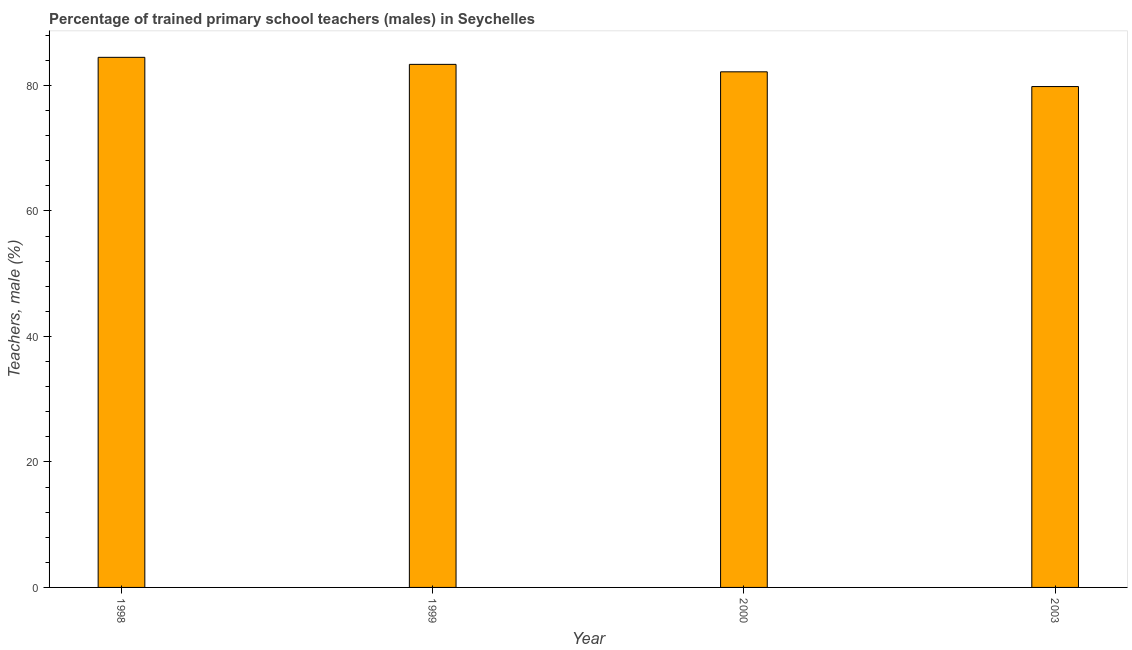Does the graph contain any zero values?
Offer a terse response. No. Does the graph contain grids?
Keep it short and to the point. No. What is the title of the graph?
Offer a terse response. Percentage of trained primary school teachers (males) in Seychelles. What is the label or title of the Y-axis?
Provide a short and direct response. Teachers, male (%). What is the percentage of trained male teachers in 2000?
Give a very brief answer. 82.17. Across all years, what is the maximum percentage of trained male teachers?
Provide a short and direct response. 84.48. Across all years, what is the minimum percentage of trained male teachers?
Give a very brief answer. 79.83. In which year was the percentage of trained male teachers minimum?
Give a very brief answer. 2003. What is the sum of the percentage of trained male teachers?
Offer a very short reply. 329.84. What is the difference between the percentage of trained male teachers in 1999 and 2003?
Your answer should be compact. 3.54. What is the average percentage of trained male teachers per year?
Offer a terse response. 82.46. What is the median percentage of trained male teachers?
Provide a short and direct response. 82.77. Do a majority of the years between 1998 and 2000 (inclusive) have percentage of trained male teachers greater than 20 %?
Your answer should be very brief. Yes. What is the ratio of the percentage of trained male teachers in 1998 to that in 1999?
Your answer should be very brief. 1.01. What is the difference between the highest and the second highest percentage of trained male teachers?
Keep it short and to the point. 1.12. Is the sum of the percentage of trained male teachers in 1998 and 1999 greater than the maximum percentage of trained male teachers across all years?
Keep it short and to the point. Yes. What is the difference between the highest and the lowest percentage of trained male teachers?
Offer a terse response. 4.66. In how many years, is the percentage of trained male teachers greater than the average percentage of trained male teachers taken over all years?
Make the answer very short. 2. Are all the bars in the graph horizontal?
Your answer should be very brief. No. Are the values on the major ticks of Y-axis written in scientific E-notation?
Offer a terse response. No. What is the Teachers, male (%) in 1998?
Ensure brevity in your answer.  84.48. What is the Teachers, male (%) in 1999?
Provide a succinct answer. 83.36. What is the Teachers, male (%) in 2000?
Provide a short and direct response. 82.17. What is the Teachers, male (%) in 2003?
Give a very brief answer. 79.83. What is the difference between the Teachers, male (%) in 1998 and 1999?
Offer a terse response. 1.12. What is the difference between the Teachers, male (%) in 1998 and 2000?
Give a very brief answer. 2.31. What is the difference between the Teachers, male (%) in 1998 and 2003?
Provide a short and direct response. 4.66. What is the difference between the Teachers, male (%) in 1999 and 2000?
Offer a very short reply. 1.19. What is the difference between the Teachers, male (%) in 1999 and 2003?
Provide a short and direct response. 3.54. What is the difference between the Teachers, male (%) in 2000 and 2003?
Offer a terse response. 2.35. What is the ratio of the Teachers, male (%) in 1998 to that in 2000?
Make the answer very short. 1.03. What is the ratio of the Teachers, male (%) in 1998 to that in 2003?
Your answer should be very brief. 1.06. What is the ratio of the Teachers, male (%) in 1999 to that in 2003?
Give a very brief answer. 1.04. 